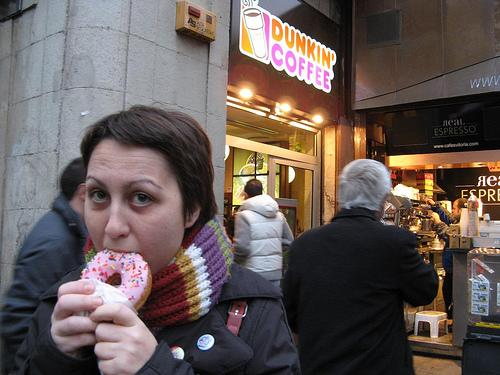What is the woman eating the donut wearing? Please explain your reasoning. scarf. There is only one woman eating a donut and the most prominent piece of clothing is answer a and none of the other answers are present on the woman. 